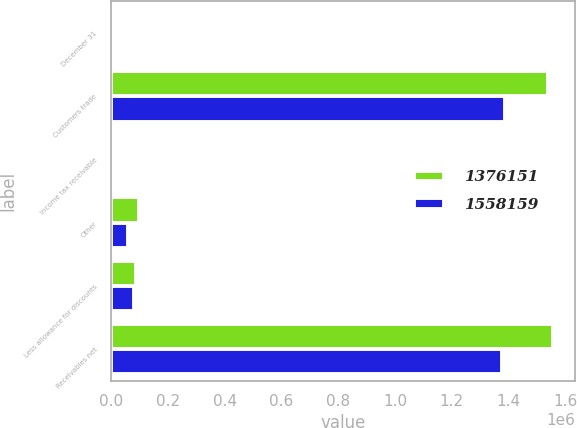<chart> <loc_0><loc_0><loc_500><loc_500><stacked_bar_chart><ecel><fcel>December 31<fcel>Customers trade<fcel>Income tax receivable<fcel>Other<fcel>Less allowance for discounts<fcel>Receivables net<nl><fcel>1.37615e+06<fcel>2017<fcel>1.53835e+06<fcel>9835<fcel>96079<fcel>86103<fcel>1.55816e+06<nl><fcel>1.55816e+06<fcel>2016<fcel>1.38631e+06<fcel>8616<fcel>59564<fcel>78335<fcel>1.37615e+06<nl></chart> 